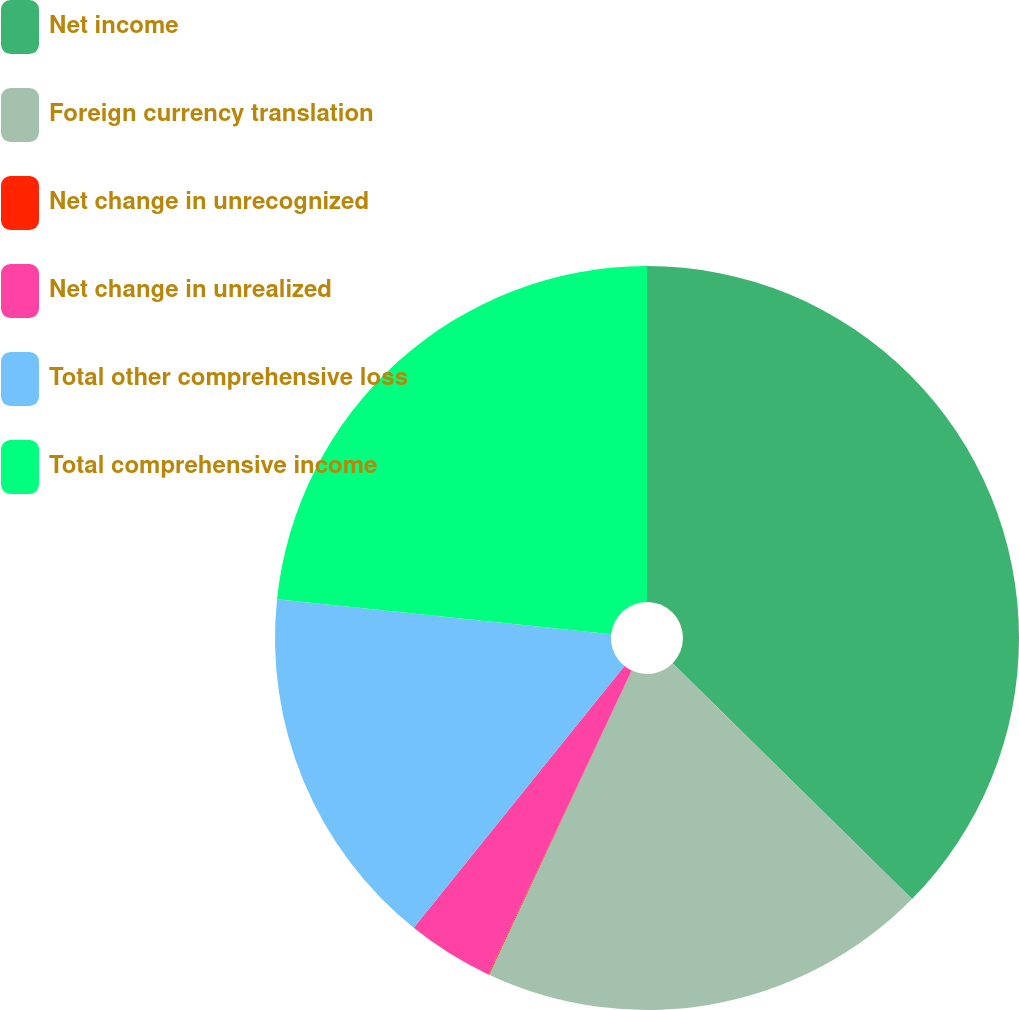Convert chart to OTSL. <chart><loc_0><loc_0><loc_500><loc_500><pie_chart><fcel>Net income<fcel>Foreign currency translation<fcel>Net change in unrecognized<fcel>Net change in unrealized<fcel>Total other comprehensive loss<fcel>Total comprehensive income<nl><fcel>37.38%<fcel>19.6%<fcel>0.04%<fcel>3.77%<fcel>15.87%<fcel>23.34%<nl></chart> 